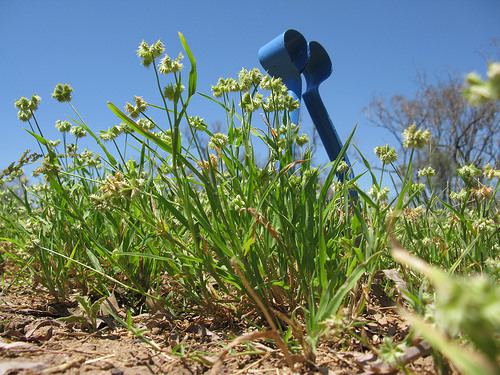<image>
Can you confirm if the sky is in front of the plant? No. The sky is not in front of the plant. The spatial positioning shows a different relationship between these objects. 